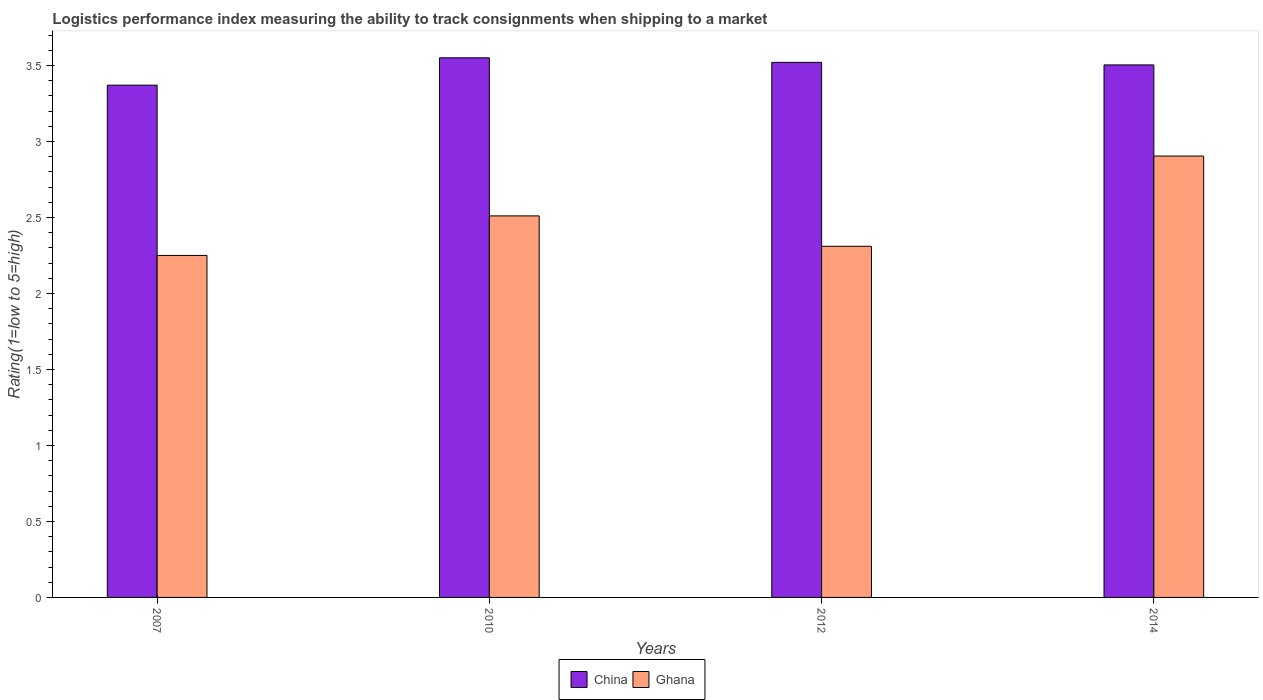How many different coloured bars are there?
Your response must be concise. 2. How many groups of bars are there?
Offer a terse response. 4. What is the label of the 1st group of bars from the left?
Give a very brief answer. 2007. What is the Logistic performance index in Ghana in 2014?
Your answer should be compact. 2.9. Across all years, what is the maximum Logistic performance index in Ghana?
Your response must be concise. 2.9. Across all years, what is the minimum Logistic performance index in Ghana?
Give a very brief answer. 2.25. In which year was the Logistic performance index in China maximum?
Provide a succinct answer. 2010. In which year was the Logistic performance index in Ghana minimum?
Keep it short and to the point. 2007. What is the total Logistic performance index in China in the graph?
Give a very brief answer. 13.94. What is the difference between the Logistic performance index in China in 2010 and that in 2014?
Your response must be concise. 0.05. What is the difference between the Logistic performance index in Ghana in 2007 and the Logistic performance index in China in 2010?
Make the answer very short. -1.3. What is the average Logistic performance index in Ghana per year?
Ensure brevity in your answer.  2.49. In the year 2007, what is the difference between the Logistic performance index in China and Logistic performance index in Ghana?
Give a very brief answer. 1.12. What is the ratio of the Logistic performance index in Ghana in 2010 to that in 2012?
Ensure brevity in your answer.  1.09. What is the difference between the highest and the second highest Logistic performance index in Ghana?
Make the answer very short. 0.39. What is the difference between the highest and the lowest Logistic performance index in Ghana?
Offer a terse response. 0.65. In how many years, is the Logistic performance index in Ghana greater than the average Logistic performance index in Ghana taken over all years?
Your answer should be very brief. 2. What does the 2nd bar from the left in 2007 represents?
Provide a short and direct response. Ghana. What does the 2nd bar from the right in 2007 represents?
Your answer should be very brief. China. How many bars are there?
Provide a succinct answer. 8. How many years are there in the graph?
Make the answer very short. 4. What is the difference between two consecutive major ticks on the Y-axis?
Your answer should be very brief. 0.5. Does the graph contain grids?
Provide a short and direct response. No. Where does the legend appear in the graph?
Provide a succinct answer. Bottom center. What is the title of the graph?
Provide a short and direct response. Logistics performance index measuring the ability to track consignments when shipping to a market. What is the label or title of the X-axis?
Ensure brevity in your answer.  Years. What is the label or title of the Y-axis?
Provide a short and direct response. Rating(1=low to 5=high). What is the Rating(1=low to 5=high) in China in 2007?
Offer a terse response. 3.37. What is the Rating(1=low to 5=high) in Ghana in 2007?
Your response must be concise. 2.25. What is the Rating(1=low to 5=high) of China in 2010?
Your answer should be very brief. 3.55. What is the Rating(1=low to 5=high) of Ghana in 2010?
Your response must be concise. 2.51. What is the Rating(1=low to 5=high) of China in 2012?
Provide a succinct answer. 3.52. What is the Rating(1=low to 5=high) in Ghana in 2012?
Make the answer very short. 2.31. What is the Rating(1=low to 5=high) in China in 2014?
Ensure brevity in your answer.  3.5. What is the Rating(1=low to 5=high) of Ghana in 2014?
Offer a very short reply. 2.9. Across all years, what is the maximum Rating(1=low to 5=high) of China?
Your response must be concise. 3.55. Across all years, what is the maximum Rating(1=low to 5=high) in Ghana?
Offer a very short reply. 2.9. Across all years, what is the minimum Rating(1=low to 5=high) in China?
Provide a short and direct response. 3.37. Across all years, what is the minimum Rating(1=low to 5=high) in Ghana?
Your response must be concise. 2.25. What is the total Rating(1=low to 5=high) of China in the graph?
Give a very brief answer. 13.94. What is the total Rating(1=low to 5=high) of Ghana in the graph?
Your response must be concise. 9.97. What is the difference between the Rating(1=low to 5=high) of China in 2007 and that in 2010?
Keep it short and to the point. -0.18. What is the difference between the Rating(1=low to 5=high) of Ghana in 2007 and that in 2010?
Make the answer very short. -0.26. What is the difference between the Rating(1=low to 5=high) of China in 2007 and that in 2012?
Ensure brevity in your answer.  -0.15. What is the difference between the Rating(1=low to 5=high) of Ghana in 2007 and that in 2012?
Provide a short and direct response. -0.06. What is the difference between the Rating(1=low to 5=high) in China in 2007 and that in 2014?
Keep it short and to the point. -0.13. What is the difference between the Rating(1=low to 5=high) of Ghana in 2007 and that in 2014?
Your response must be concise. -0.65. What is the difference between the Rating(1=low to 5=high) of China in 2010 and that in 2012?
Make the answer very short. 0.03. What is the difference between the Rating(1=low to 5=high) in Ghana in 2010 and that in 2012?
Make the answer very short. 0.2. What is the difference between the Rating(1=low to 5=high) in China in 2010 and that in 2014?
Provide a short and direct response. 0.05. What is the difference between the Rating(1=low to 5=high) in Ghana in 2010 and that in 2014?
Make the answer very short. -0.39. What is the difference between the Rating(1=low to 5=high) in China in 2012 and that in 2014?
Your answer should be very brief. 0.02. What is the difference between the Rating(1=low to 5=high) in Ghana in 2012 and that in 2014?
Ensure brevity in your answer.  -0.59. What is the difference between the Rating(1=low to 5=high) in China in 2007 and the Rating(1=low to 5=high) in Ghana in 2010?
Ensure brevity in your answer.  0.86. What is the difference between the Rating(1=low to 5=high) of China in 2007 and the Rating(1=low to 5=high) of Ghana in 2012?
Ensure brevity in your answer.  1.06. What is the difference between the Rating(1=low to 5=high) in China in 2007 and the Rating(1=low to 5=high) in Ghana in 2014?
Your answer should be compact. 0.47. What is the difference between the Rating(1=low to 5=high) in China in 2010 and the Rating(1=low to 5=high) in Ghana in 2012?
Keep it short and to the point. 1.24. What is the difference between the Rating(1=low to 5=high) of China in 2010 and the Rating(1=low to 5=high) of Ghana in 2014?
Your response must be concise. 0.65. What is the difference between the Rating(1=low to 5=high) of China in 2012 and the Rating(1=low to 5=high) of Ghana in 2014?
Your response must be concise. 0.62. What is the average Rating(1=low to 5=high) of China per year?
Provide a short and direct response. 3.49. What is the average Rating(1=low to 5=high) in Ghana per year?
Make the answer very short. 2.49. In the year 2007, what is the difference between the Rating(1=low to 5=high) of China and Rating(1=low to 5=high) of Ghana?
Make the answer very short. 1.12. In the year 2010, what is the difference between the Rating(1=low to 5=high) in China and Rating(1=low to 5=high) in Ghana?
Make the answer very short. 1.04. In the year 2012, what is the difference between the Rating(1=low to 5=high) in China and Rating(1=low to 5=high) in Ghana?
Your response must be concise. 1.21. In the year 2014, what is the difference between the Rating(1=low to 5=high) of China and Rating(1=low to 5=high) of Ghana?
Give a very brief answer. 0.6. What is the ratio of the Rating(1=low to 5=high) in China in 2007 to that in 2010?
Your response must be concise. 0.95. What is the ratio of the Rating(1=low to 5=high) in Ghana in 2007 to that in 2010?
Offer a terse response. 0.9. What is the ratio of the Rating(1=low to 5=high) of China in 2007 to that in 2012?
Make the answer very short. 0.96. What is the ratio of the Rating(1=low to 5=high) in Ghana in 2007 to that in 2012?
Your answer should be compact. 0.97. What is the ratio of the Rating(1=low to 5=high) of China in 2007 to that in 2014?
Make the answer very short. 0.96. What is the ratio of the Rating(1=low to 5=high) of Ghana in 2007 to that in 2014?
Your response must be concise. 0.77. What is the ratio of the Rating(1=low to 5=high) of China in 2010 to that in 2012?
Provide a short and direct response. 1.01. What is the ratio of the Rating(1=low to 5=high) in Ghana in 2010 to that in 2012?
Offer a terse response. 1.09. What is the ratio of the Rating(1=low to 5=high) of China in 2010 to that in 2014?
Ensure brevity in your answer.  1.01. What is the ratio of the Rating(1=low to 5=high) of Ghana in 2010 to that in 2014?
Keep it short and to the point. 0.86. What is the ratio of the Rating(1=low to 5=high) of China in 2012 to that in 2014?
Offer a terse response. 1. What is the ratio of the Rating(1=low to 5=high) in Ghana in 2012 to that in 2014?
Ensure brevity in your answer.  0.8. What is the difference between the highest and the second highest Rating(1=low to 5=high) in Ghana?
Offer a very short reply. 0.39. What is the difference between the highest and the lowest Rating(1=low to 5=high) in China?
Make the answer very short. 0.18. What is the difference between the highest and the lowest Rating(1=low to 5=high) of Ghana?
Provide a short and direct response. 0.65. 